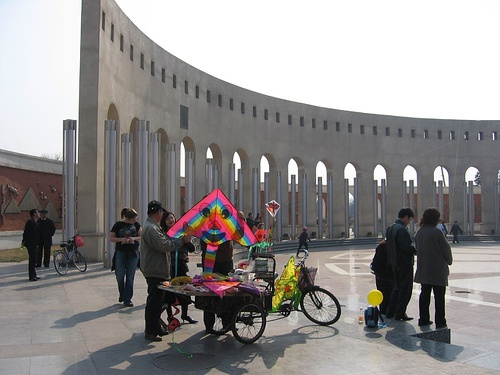Describe the objects in this image and their specific colors. I can see bicycle in lavender, black, darkgray, gray, and olive tones, people in lavender, black, gray, darkgray, and lightgray tones, people in lavender, black, and gray tones, kite in lavender, salmon, black, maroon, and brown tones, and people in lavender, black, and gray tones in this image. 